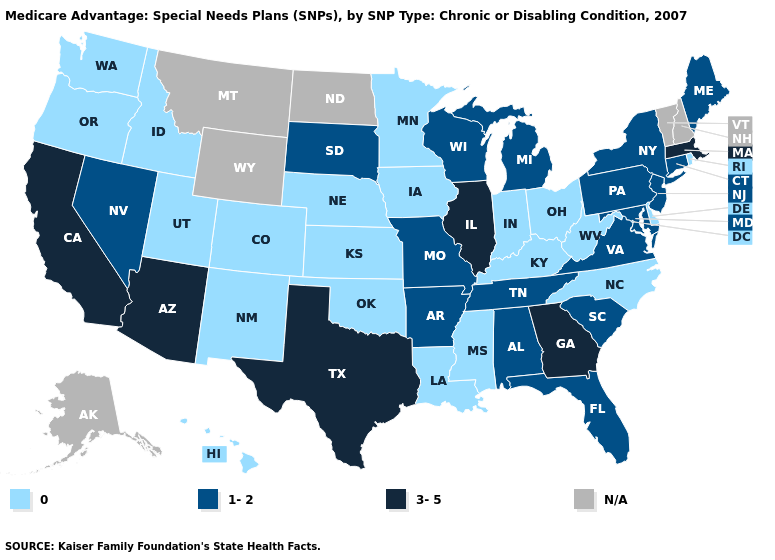What is the value of Iowa?
Give a very brief answer. 0. What is the highest value in the USA?
Quick response, please. 3-5. Which states hav the highest value in the Northeast?
Write a very short answer. Massachusetts. What is the value of Oregon?
Answer briefly. 0. Which states have the lowest value in the USA?
Short answer required. Colorado, Delaware, Hawaii, Iowa, Idaho, Indiana, Kansas, Kentucky, Louisiana, Minnesota, Mississippi, North Carolina, Nebraska, New Mexico, Ohio, Oklahoma, Oregon, Rhode Island, Utah, Washington, West Virginia. Among the states that border Alabama , which have the highest value?
Short answer required. Georgia. Name the states that have a value in the range 0?
Write a very short answer. Colorado, Delaware, Hawaii, Iowa, Idaho, Indiana, Kansas, Kentucky, Louisiana, Minnesota, Mississippi, North Carolina, Nebraska, New Mexico, Ohio, Oklahoma, Oregon, Rhode Island, Utah, Washington, West Virginia. Among the states that border New Hampshire , does Massachusetts have the highest value?
Answer briefly. Yes. Which states have the lowest value in the Northeast?
Quick response, please. Rhode Island. Which states have the lowest value in the USA?
Short answer required. Colorado, Delaware, Hawaii, Iowa, Idaho, Indiana, Kansas, Kentucky, Louisiana, Minnesota, Mississippi, North Carolina, Nebraska, New Mexico, Ohio, Oklahoma, Oregon, Rhode Island, Utah, Washington, West Virginia. What is the value of Maine?
Keep it brief. 1-2. Does Pennsylvania have the lowest value in the USA?
Quick response, please. No. Name the states that have a value in the range N/A?
Be succinct. Alaska, Montana, North Dakota, New Hampshire, Vermont, Wyoming. What is the value of Kansas?
Answer briefly. 0. 